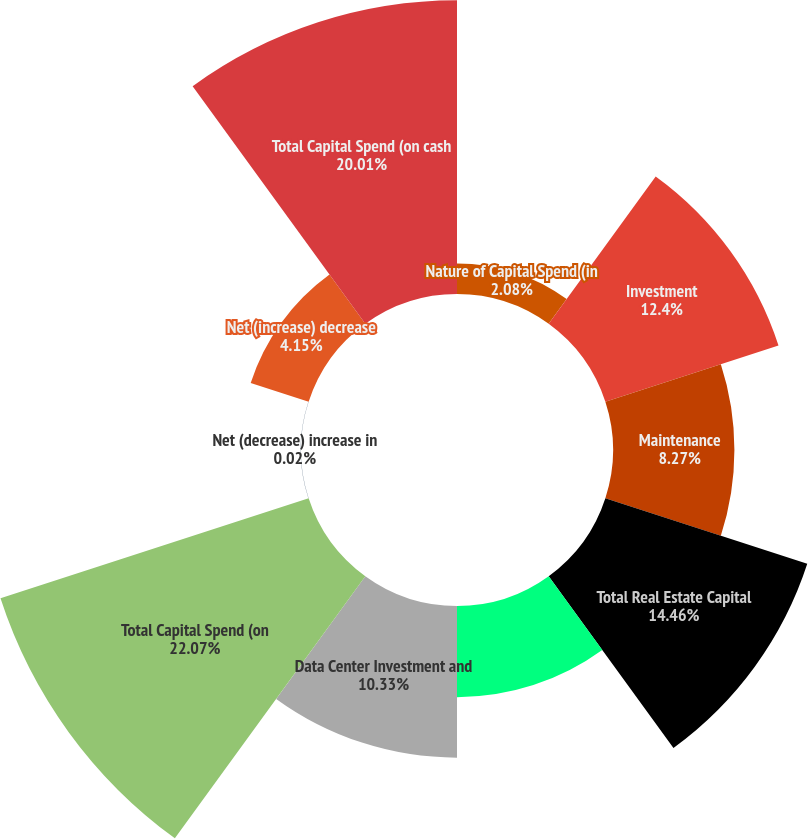Convert chart. <chart><loc_0><loc_0><loc_500><loc_500><pie_chart><fcel>Nature of Capital Spend (in<fcel>Investment<fcel>Maintenance<fcel>Total Real Estate Capital<fcel>Total Non-Real Estate Capital<fcel>Data Center Investment and<fcel>Total Capital Spend (on<fcel>Net (decrease) increase in<fcel>Net (increase) decrease<fcel>Total Capital Spend (on cash<nl><fcel>2.08%<fcel>12.4%<fcel>8.27%<fcel>14.46%<fcel>6.21%<fcel>10.33%<fcel>22.07%<fcel>0.02%<fcel>4.15%<fcel>20.01%<nl></chart> 